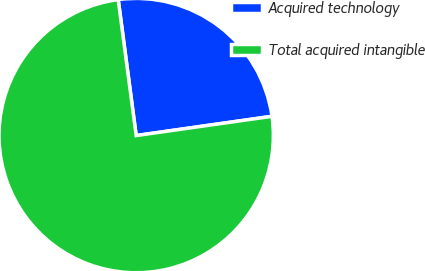Convert chart to OTSL. <chart><loc_0><loc_0><loc_500><loc_500><pie_chart><fcel>Acquired technology<fcel>Total acquired intangible<nl><fcel>24.85%<fcel>75.15%<nl></chart> 